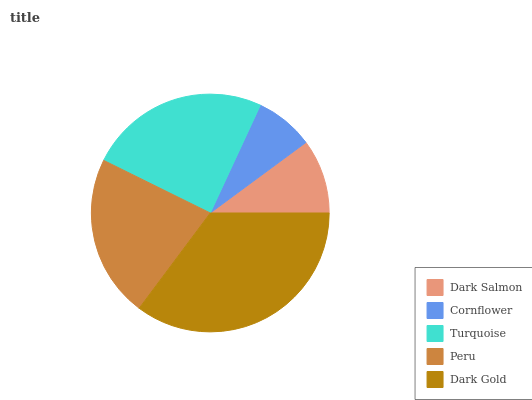Is Cornflower the minimum?
Answer yes or no. Yes. Is Dark Gold the maximum?
Answer yes or no. Yes. Is Turquoise the minimum?
Answer yes or no. No. Is Turquoise the maximum?
Answer yes or no. No. Is Turquoise greater than Cornflower?
Answer yes or no. Yes. Is Cornflower less than Turquoise?
Answer yes or no. Yes. Is Cornflower greater than Turquoise?
Answer yes or no. No. Is Turquoise less than Cornflower?
Answer yes or no. No. Is Peru the high median?
Answer yes or no. Yes. Is Peru the low median?
Answer yes or no. Yes. Is Dark Salmon the high median?
Answer yes or no. No. Is Dark Gold the low median?
Answer yes or no. No. 